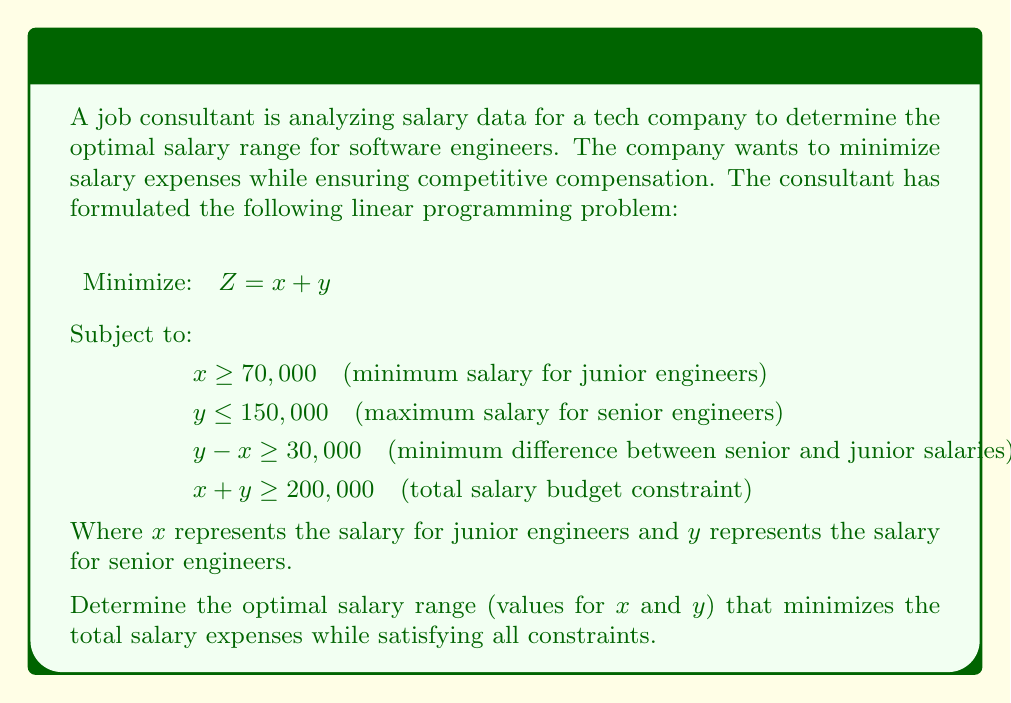What is the answer to this math problem? To solve this linear programming problem, we'll use the graphical method:

1. Plot the constraints:
   a. $x \geq 70,000$: Vertical line at $x = 70,000$
   b. $y \leq 150,000$: Horizontal line at $y = 150,000$
   c. $y - x \geq 30,000$: Line $y = x + 30,000$
   d. $x + y \geq 200,000$: Line $y = -x + 200,000$

2. Identify the feasible region:
   The feasible region is the area that satisfies all constraints simultaneously.

3. Find the corner points of the feasible region:
   A: (70,000, 150,000)
   B: (70,000, 130,000)
   C: (85,000, 115,000)

4. Evaluate the objective function $Z = x + y$ at each corner point:
   A: $Z = 70,000 + 150,000 = 220,000$
   B: $Z = 70,000 + 130,000 = 200,000$
   C: $Z = 85,000 + 115,000 = 200,000$

5. The minimum value of $Z$ occurs at both points B and C, with $Z = 200,000$.

6. Since there are two optimal solutions, we can choose either one:
   B: $x = 70,000, y = 130,000$
   C: $x = 85,000, y = 115,000$

Both solutions satisfy all constraints and minimize the total salary expenses.
Answer: Optimal salary range: Junior engineers: $70,000-$85,000; Senior engineers: $115,000-$130,000 